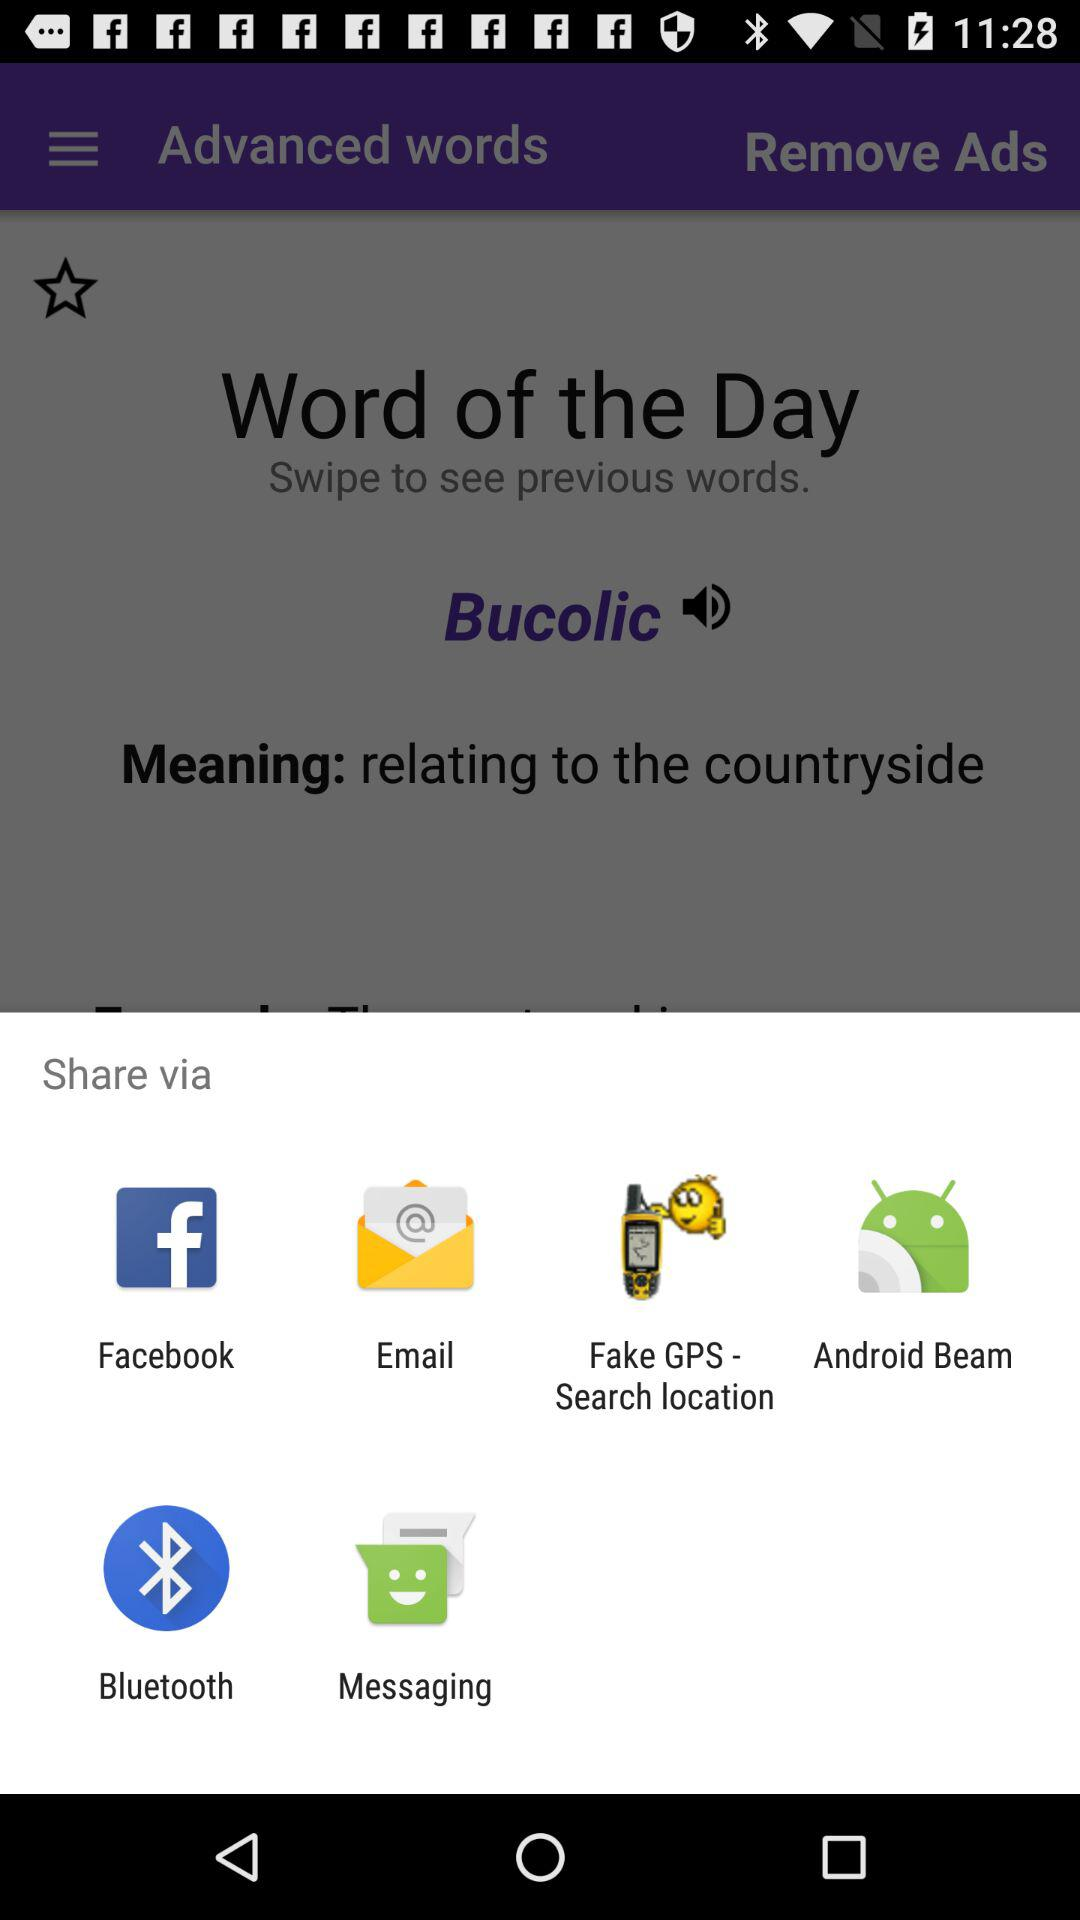What apps choose to share? The apps are "Facebook", "Email", "Fake GPS - Search location", "Android Beam", "Bluetooth" and "Messaging". 